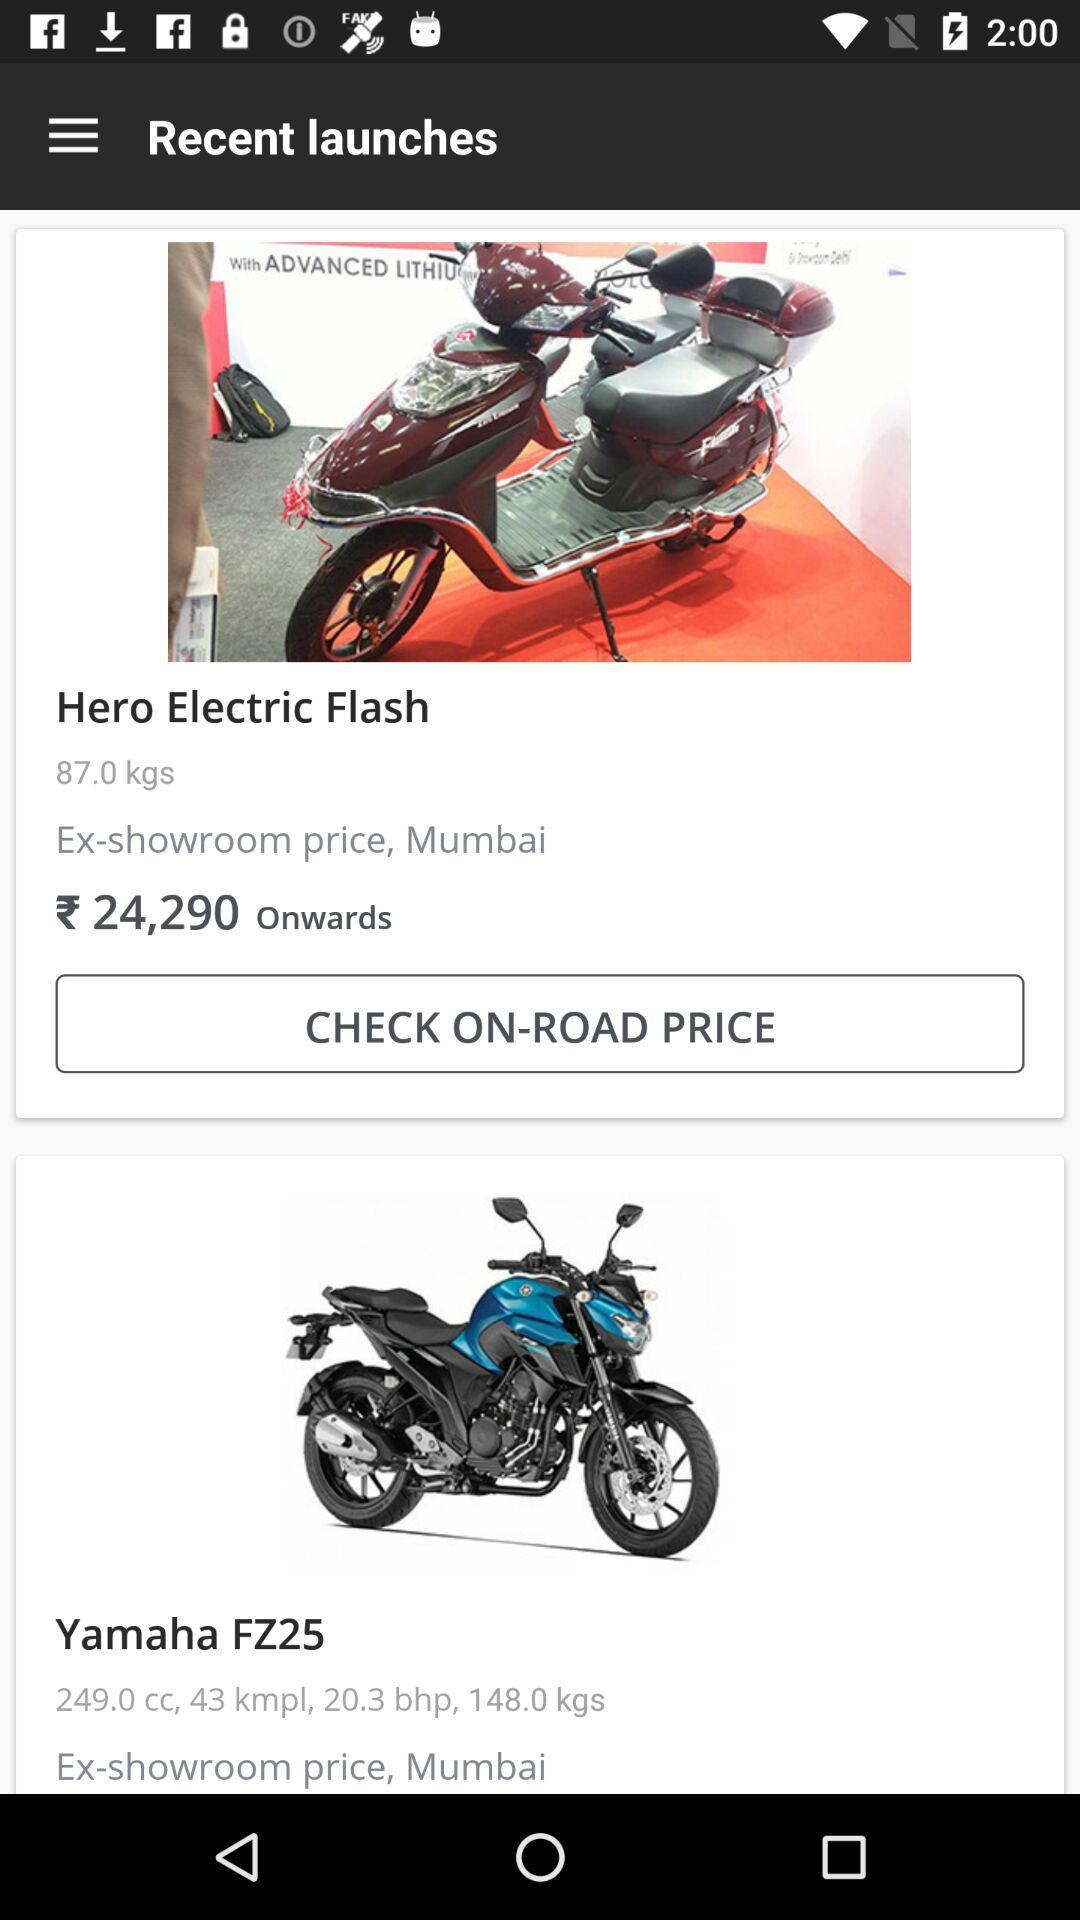What mileage has been given for "Yamaha FZ25"? The given mileage is 43 kmpl. 